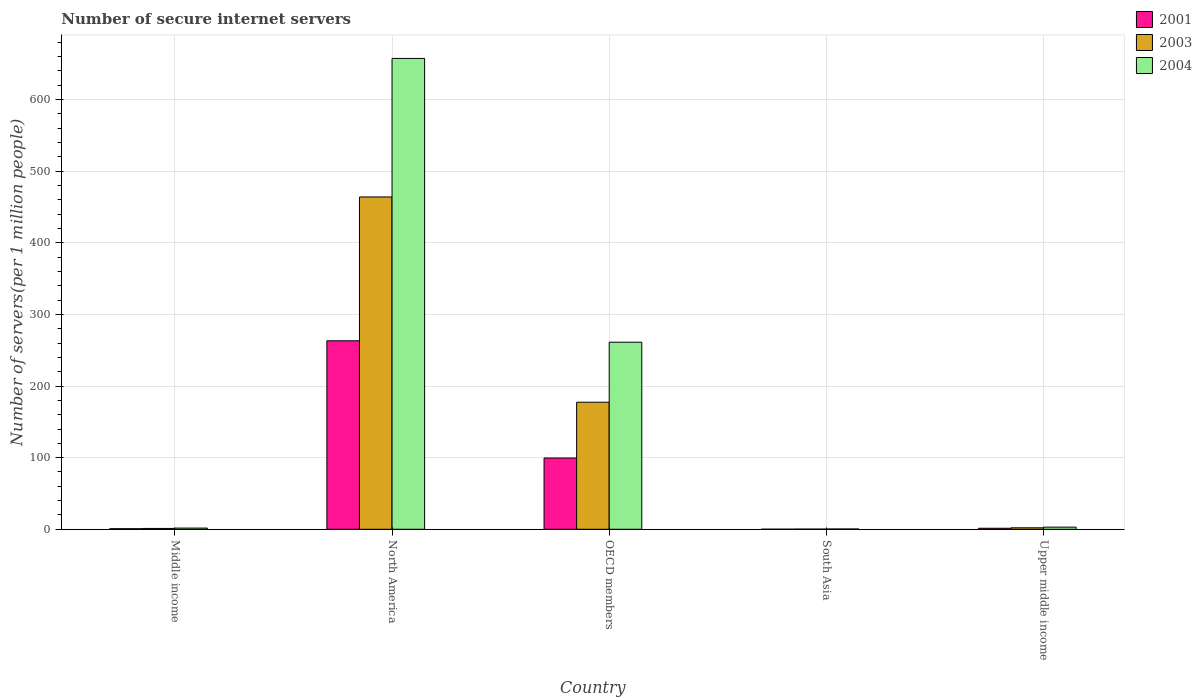How many different coloured bars are there?
Keep it short and to the point. 3. Are the number of bars per tick equal to the number of legend labels?
Provide a short and direct response. Yes. How many bars are there on the 2nd tick from the right?
Ensure brevity in your answer.  3. In how many cases, is the number of bars for a given country not equal to the number of legend labels?
Give a very brief answer. 0. What is the number of secure internet servers in 2003 in North America?
Your answer should be very brief. 464.07. Across all countries, what is the maximum number of secure internet servers in 2003?
Provide a short and direct response. 464.07. Across all countries, what is the minimum number of secure internet servers in 2001?
Your answer should be very brief. 0.1. In which country was the number of secure internet servers in 2003 minimum?
Keep it short and to the point. South Asia. What is the total number of secure internet servers in 2003 in the graph?
Provide a succinct answer. 644.94. What is the difference between the number of secure internet servers in 2004 in Middle income and that in Upper middle income?
Your answer should be compact. -1.33. What is the difference between the number of secure internet servers in 2001 in South Asia and the number of secure internet servers in 2004 in Upper middle income?
Give a very brief answer. -2.9. What is the average number of secure internet servers in 2003 per country?
Make the answer very short. 128.99. What is the difference between the number of secure internet servers of/in 2004 and number of secure internet servers of/in 2001 in North America?
Give a very brief answer. 394.33. What is the ratio of the number of secure internet servers in 2003 in North America to that in OECD members?
Offer a very short reply. 2.62. Is the number of secure internet servers in 2003 in North America less than that in Upper middle income?
Provide a succinct answer. No. Is the difference between the number of secure internet servers in 2004 in North America and South Asia greater than the difference between the number of secure internet servers in 2001 in North America and South Asia?
Provide a short and direct response. Yes. What is the difference between the highest and the second highest number of secure internet servers in 2001?
Give a very brief answer. -98.11. What is the difference between the highest and the lowest number of secure internet servers in 2001?
Provide a short and direct response. 263.14. In how many countries, is the number of secure internet servers in 2001 greater than the average number of secure internet servers in 2001 taken over all countries?
Make the answer very short. 2. Is the sum of the number of secure internet servers in 2003 in OECD members and South Asia greater than the maximum number of secure internet servers in 2001 across all countries?
Offer a very short reply. No. What does the 1st bar from the right in Middle income represents?
Offer a terse response. 2004. How many bars are there?
Ensure brevity in your answer.  15. Are all the bars in the graph horizontal?
Offer a very short reply. No. How many countries are there in the graph?
Ensure brevity in your answer.  5. What is the difference between two consecutive major ticks on the Y-axis?
Keep it short and to the point. 100. Does the graph contain any zero values?
Your response must be concise. No. Does the graph contain grids?
Your answer should be very brief. Yes. Where does the legend appear in the graph?
Your answer should be very brief. Top right. How many legend labels are there?
Offer a very short reply. 3. What is the title of the graph?
Ensure brevity in your answer.  Number of secure internet servers. What is the label or title of the X-axis?
Provide a short and direct response. Country. What is the label or title of the Y-axis?
Offer a terse response. Number of servers(per 1 million people). What is the Number of servers(per 1 million people) in 2001 in Middle income?
Your response must be concise. 0.78. What is the Number of servers(per 1 million people) in 2003 in Middle income?
Ensure brevity in your answer.  1.15. What is the Number of servers(per 1 million people) of 2004 in Middle income?
Your answer should be very brief. 1.67. What is the Number of servers(per 1 million people) of 2001 in North America?
Make the answer very short. 263.23. What is the Number of servers(per 1 million people) in 2003 in North America?
Keep it short and to the point. 464.07. What is the Number of servers(per 1 million people) in 2004 in North America?
Your answer should be compact. 657.56. What is the Number of servers(per 1 million people) of 2001 in OECD members?
Offer a terse response. 99.52. What is the Number of servers(per 1 million people) in 2003 in OECD members?
Your response must be concise. 177.43. What is the Number of servers(per 1 million people) in 2004 in OECD members?
Offer a very short reply. 261.25. What is the Number of servers(per 1 million people) of 2001 in South Asia?
Keep it short and to the point. 0.1. What is the Number of servers(per 1 million people) in 2003 in South Asia?
Provide a succinct answer. 0.23. What is the Number of servers(per 1 million people) of 2004 in South Asia?
Give a very brief answer. 0.36. What is the Number of servers(per 1 million people) in 2001 in Upper middle income?
Your response must be concise. 1.41. What is the Number of servers(per 1 million people) of 2003 in Upper middle income?
Give a very brief answer. 2.06. What is the Number of servers(per 1 million people) in 2004 in Upper middle income?
Offer a very short reply. 3. Across all countries, what is the maximum Number of servers(per 1 million people) of 2001?
Your answer should be compact. 263.23. Across all countries, what is the maximum Number of servers(per 1 million people) in 2003?
Your answer should be compact. 464.07. Across all countries, what is the maximum Number of servers(per 1 million people) in 2004?
Offer a terse response. 657.56. Across all countries, what is the minimum Number of servers(per 1 million people) in 2001?
Your answer should be very brief. 0.1. Across all countries, what is the minimum Number of servers(per 1 million people) of 2003?
Ensure brevity in your answer.  0.23. Across all countries, what is the minimum Number of servers(per 1 million people) in 2004?
Offer a terse response. 0.36. What is the total Number of servers(per 1 million people) in 2001 in the graph?
Offer a terse response. 365.04. What is the total Number of servers(per 1 million people) of 2003 in the graph?
Make the answer very short. 644.94. What is the total Number of servers(per 1 million people) of 2004 in the graph?
Offer a terse response. 923.84. What is the difference between the Number of servers(per 1 million people) of 2001 in Middle income and that in North America?
Offer a very short reply. -262.46. What is the difference between the Number of servers(per 1 million people) in 2003 in Middle income and that in North America?
Your answer should be very brief. -462.93. What is the difference between the Number of servers(per 1 million people) in 2004 in Middle income and that in North America?
Keep it short and to the point. -655.89. What is the difference between the Number of servers(per 1 million people) of 2001 in Middle income and that in OECD members?
Offer a terse response. -98.74. What is the difference between the Number of servers(per 1 million people) in 2003 in Middle income and that in OECD members?
Give a very brief answer. -176.28. What is the difference between the Number of servers(per 1 million people) of 2004 in Middle income and that in OECD members?
Make the answer very short. -259.58. What is the difference between the Number of servers(per 1 million people) of 2001 in Middle income and that in South Asia?
Provide a succinct answer. 0.68. What is the difference between the Number of servers(per 1 million people) in 2003 in Middle income and that in South Asia?
Keep it short and to the point. 0.92. What is the difference between the Number of servers(per 1 million people) of 2004 in Middle income and that in South Asia?
Ensure brevity in your answer.  1.31. What is the difference between the Number of servers(per 1 million people) of 2001 in Middle income and that in Upper middle income?
Make the answer very short. -0.63. What is the difference between the Number of servers(per 1 million people) of 2003 in Middle income and that in Upper middle income?
Offer a very short reply. -0.91. What is the difference between the Number of servers(per 1 million people) in 2004 in Middle income and that in Upper middle income?
Give a very brief answer. -1.33. What is the difference between the Number of servers(per 1 million people) of 2001 in North America and that in OECD members?
Ensure brevity in your answer.  163.72. What is the difference between the Number of servers(per 1 million people) of 2003 in North America and that in OECD members?
Offer a terse response. 286.65. What is the difference between the Number of servers(per 1 million people) in 2004 in North America and that in OECD members?
Provide a succinct answer. 396.32. What is the difference between the Number of servers(per 1 million people) in 2001 in North America and that in South Asia?
Give a very brief answer. 263.14. What is the difference between the Number of servers(per 1 million people) in 2003 in North America and that in South Asia?
Your response must be concise. 463.85. What is the difference between the Number of servers(per 1 million people) of 2004 in North America and that in South Asia?
Keep it short and to the point. 657.2. What is the difference between the Number of servers(per 1 million people) of 2001 in North America and that in Upper middle income?
Give a very brief answer. 261.83. What is the difference between the Number of servers(per 1 million people) of 2003 in North America and that in Upper middle income?
Make the answer very short. 462.01. What is the difference between the Number of servers(per 1 million people) of 2004 in North America and that in Upper middle income?
Ensure brevity in your answer.  654.57. What is the difference between the Number of servers(per 1 million people) of 2001 in OECD members and that in South Asia?
Offer a very short reply. 99.42. What is the difference between the Number of servers(per 1 million people) in 2003 in OECD members and that in South Asia?
Provide a short and direct response. 177.2. What is the difference between the Number of servers(per 1 million people) of 2004 in OECD members and that in South Asia?
Keep it short and to the point. 260.88. What is the difference between the Number of servers(per 1 million people) of 2001 in OECD members and that in Upper middle income?
Your response must be concise. 98.11. What is the difference between the Number of servers(per 1 million people) in 2003 in OECD members and that in Upper middle income?
Keep it short and to the point. 175.36. What is the difference between the Number of servers(per 1 million people) of 2004 in OECD members and that in Upper middle income?
Give a very brief answer. 258.25. What is the difference between the Number of servers(per 1 million people) of 2001 in South Asia and that in Upper middle income?
Ensure brevity in your answer.  -1.31. What is the difference between the Number of servers(per 1 million people) of 2003 in South Asia and that in Upper middle income?
Give a very brief answer. -1.83. What is the difference between the Number of servers(per 1 million people) of 2004 in South Asia and that in Upper middle income?
Your answer should be very brief. -2.63. What is the difference between the Number of servers(per 1 million people) of 2001 in Middle income and the Number of servers(per 1 million people) of 2003 in North America?
Offer a very short reply. -463.3. What is the difference between the Number of servers(per 1 million people) in 2001 in Middle income and the Number of servers(per 1 million people) in 2004 in North America?
Provide a succinct answer. -656.79. What is the difference between the Number of servers(per 1 million people) of 2003 in Middle income and the Number of servers(per 1 million people) of 2004 in North America?
Your response must be concise. -656.42. What is the difference between the Number of servers(per 1 million people) in 2001 in Middle income and the Number of servers(per 1 million people) in 2003 in OECD members?
Your answer should be very brief. -176.65. What is the difference between the Number of servers(per 1 million people) of 2001 in Middle income and the Number of servers(per 1 million people) of 2004 in OECD members?
Provide a short and direct response. -260.47. What is the difference between the Number of servers(per 1 million people) of 2003 in Middle income and the Number of servers(per 1 million people) of 2004 in OECD members?
Provide a succinct answer. -260.1. What is the difference between the Number of servers(per 1 million people) in 2001 in Middle income and the Number of servers(per 1 million people) in 2003 in South Asia?
Give a very brief answer. 0.55. What is the difference between the Number of servers(per 1 million people) in 2001 in Middle income and the Number of servers(per 1 million people) in 2004 in South Asia?
Ensure brevity in your answer.  0.41. What is the difference between the Number of servers(per 1 million people) of 2003 in Middle income and the Number of servers(per 1 million people) of 2004 in South Asia?
Your answer should be very brief. 0.78. What is the difference between the Number of servers(per 1 million people) of 2001 in Middle income and the Number of servers(per 1 million people) of 2003 in Upper middle income?
Provide a succinct answer. -1.28. What is the difference between the Number of servers(per 1 million people) of 2001 in Middle income and the Number of servers(per 1 million people) of 2004 in Upper middle income?
Give a very brief answer. -2.22. What is the difference between the Number of servers(per 1 million people) in 2003 in Middle income and the Number of servers(per 1 million people) in 2004 in Upper middle income?
Give a very brief answer. -1.85. What is the difference between the Number of servers(per 1 million people) in 2001 in North America and the Number of servers(per 1 million people) in 2003 in OECD members?
Your response must be concise. 85.81. What is the difference between the Number of servers(per 1 million people) in 2001 in North America and the Number of servers(per 1 million people) in 2004 in OECD members?
Ensure brevity in your answer.  1.99. What is the difference between the Number of servers(per 1 million people) of 2003 in North America and the Number of servers(per 1 million people) of 2004 in OECD members?
Offer a terse response. 202.83. What is the difference between the Number of servers(per 1 million people) in 2001 in North America and the Number of servers(per 1 million people) in 2003 in South Asia?
Offer a very short reply. 263.01. What is the difference between the Number of servers(per 1 million people) in 2001 in North America and the Number of servers(per 1 million people) in 2004 in South Asia?
Your answer should be very brief. 262.87. What is the difference between the Number of servers(per 1 million people) in 2003 in North America and the Number of servers(per 1 million people) in 2004 in South Asia?
Provide a short and direct response. 463.71. What is the difference between the Number of servers(per 1 million people) in 2001 in North America and the Number of servers(per 1 million people) in 2003 in Upper middle income?
Offer a very short reply. 261.17. What is the difference between the Number of servers(per 1 million people) of 2001 in North America and the Number of servers(per 1 million people) of 2004 in Upper middle income?
Offer a terse response. 260.24. What is the difference between the Number of servers(per 1 million people) in 2003 in North America and the Number of servers(per 1 million people) in 2004 in Upper middle income?
Provide a succinct answer. 461.08. What is the difference between the Number of servers(per 1 million people) of 2001 in OECD members and the Number of servers(per 1 million people) of 2003 in South Asia?
Your response must be concise. 99.29. What is the difference between the Number of servers(per 1 million people) in 2001 in OECD members and the Number of servers(per 1 million people) in 2004 in South Asia?
Ensure brevity in your answer.  99.15. What is the difference between the Number of servers(per 1 million people) of 2003 in OECD members and the Number of servers(per 1 million people) of 2004 in South Asia?
Offer a very short reply. 177.06. What is the difference between the Number of servers(per 1 million people) in 2001 in OECD members and the Number of servers(per 1 million people) in 2003 in Upper middle income?
Offer a very short reply. 97.45. What is the difference between the Number of servers(per 1 million people) in 2001 in OECD members and the Number of servers(per 1 million people) in 2004 in Upper middle income?
Your response must be concise. 96.52. What is the difference between the Number of servers(per 1 million people) in 2003 in OECD members and the Number of servers(per 1 million people) in 2004 in Upper middle income?
Offer a very short reply. 174.43. What is the difference between the Number of servers(per 1 million people) of 2001 in South Asia and the Number of servers(per 1 million people) of 2003 in Upper middle income?
Give a very brief answer. -1.96. What is the difference between the Number of servers(per 1 million people) of 2001 in South Asia and the Number of servers(per 1 million people) of 2004 in Upper middle income?
Your response must be concise. -2.9. What is the difference between the Number of servers(per 1 million people) of 2003 in South Asia and the Number of servers(per 1 million people) of 2004 in Upper middle income?
Your answer should be compact. -2.77. What is the average Number of servers(per 1 million people) of 2001 per country?
Provide a short and direct response. 73.01. What is the average Number of servers(per 1 million people) in 2003 per country?
Ensure brevity in your answer.  128.99. What is the average Number of servers(per 1 million people) of 2004 per country?
Ensure brevity in your answer.  184.77. What is the difference between the Number of servers(per 1 million people) in 2001 and Number of servers(per 1 million people) in 2003 in Middle income?
Provide a succinct answer. -0.37. What is the difference between the Number of servers(per 1 million people) of 2001 and Number of servers(per 1 million people) of 2004 in Middle income?
Give a very brief answer. -0.89. What is the difference between the Number of servers(per 1 million people) in 2003 and Number of servers(per 1 million people) in 2004 in Middle income?
Provide a short and direct response. -0.52. What is the difference between the Number of servers(per 1 million people) of 2001 and Number of servers(per 1 million people) of 2003 in North America?
Give a very brief answer. -200.84. What is the difference between the Number of servers(per 1 million people) of 2001 and Number of servers(per 1 million people) of 2004 in North America?
Keep it short and to the point. -394.33. What is the difference between the Number of servers(per 1 million people) of 2003 and Number of servers(per 1 million people) of 2004 in North America?
Offer a very short reply. -193.49. What is the difference between the Number of servers(per 1 million people) in 2001 and Number of servers(per 1 million people) in 2003 in OECD members?
Your answer should be very brief. -77.91. What is the difference between the Number of servers(per 1 million people) of 2001 and Number of servers(per 1 million people) of 2004 in OECD members?
Provide a short and direct response. -161.73. What is the difference between the Number of servers(per 1 million people) in 2003 and Number of servers(per 1 million people) in 2004 in OECD members?
Ensure brevity in your answer.  -83.82. What is the difference between the Number of servers(per 1 million people) in 2001 and Number of servers(per 1 million people) in 2003 in South Asia?
Your answer should be very brief. -0.13. What is the difference between the Number of servers(per 1 million people) of 2001 and Number of servers(per 1 million people) of 2004 in South Asia?
Keep it short and to the point. -0.27. What is the difference between the Number of servers(per 1 million people) of 2003 and Number of servers(per 1 million people) of 2004 in South Asia?
Offer a terse response. -0.14. What is the difference between the Number of servers(per 1 million people) in 2001 and Number of servers(per 1 million people) in 2003 in Upper middle income?
Offer a terse response. -0.65. What is the difference between the Number of servers(per 1 million people) of 2001 and Number of servers(per 1 million people) of 2004 in Upper middle income?
Keep it short and to the point. -1.59. What is the difference between the Number of servers(per 1 million people) of 2003 and Number of servers(per 1 million people) of 2004 in Upper middle income?
Keep it short and to the point. -0.94. What is the ratio of the Number of servers(per 1 million people) in 2001 in Middle income to that in North America?
Your answer should be very brief. 0. What is the ratio of the Number of servers(per 1 million people) in 2003 in Middle income to that in North America?
Ensure brevity in your answer.  0. What is the ratio of the Number of servers(per 1 million people) of 2004 in Middle income to that in North America?
Your answer should be very brief. 0. What is the ratio of the Number of servers(per 1 million people) in 2001 in Middle income to that in OECD members?
Offer a very short reply. 0.01. What is the ratio of the Number of servers(per 1 million people) of 2003 in Middle income to that in OECD members?
Your answer should be compact. 0.01. What is the ratio of the Number of servers(per 1 million people) of 2004 in Middle income to that in OECD members?
Your answer should be very brief. 0.01. What is the ratio of the Number of servers(per 1 million people) of 2001 in Middle income to that in South Asia?
Your answer should be compact. 7.86. What is the ratio of the Number of servers(per 1 million people) in 2003 in Middle income to that in South Asia?
Give a very brief answer. 5.04. What is the ratio of the Number of servers(per 1 million people) of 2004 in Middle income to that in South Asia?
Your answer should be compact. 4.59. What is the ratio of the Number of servers(per 1 million people) in 2001 in Middle income to that in Upper middle income?
Offer a very short reply. 0.55. What is the ratio of the Number of servers(per 1 million people) of 2003 in Middle income to that in Upper middle income?
Provide a short and direct response. 0.56. What is the ratio of the Number of servers(per 1 million people) of 2004 in Middle income to that in Upper middle income?
Your response must be concise. 0.56. What is the ratio of the Number of servers(per 1 million people) of 2001 in North America to that in OECD members?
Give a very brief answer. 2.65. What is the ratio of the Number of servers(per 1 million people) of 2003 in North America to that in OECD members?
Give a very brief answer. 2.62. What is the ratio of the Number of servers(per 1 million people) of 2004 in North America to that in OECD members?
Your answer should be very brief. 2.52. What is the ratio of the Number of servers(per 1 million people) of 2001 in North America to that in South Asia?
Provide a short and direct response. 2663.04. What is the ratio of the Number of servers(per 1 million people) in 2003 in North America to that in South Asia?
Provide a short and direct response. 2035.75. What is the ratio of the Number of servers(per 1 million people) of 2004 in North America to that in South Asia?
Your response must be concise. 1805.77. What is the ratio of the Number of servers(per 1 million people) in 2001 in North America to that in Upper middle income?
Your response must be concise. 186.8. What is the ratio of the Number of servers(per 1 million people) of 2003 in North America to that in Upper middle income?
Provide a succinct answer. 225.17. What is the ratio of the Number of servers(per 1 million people) of 2004 in North America to that in Upper middle income?
Keep it short and to the point. 219.48. What is the ratio of the Number of servers(per 1 million people) in 2001 in OECD members to that in South Asia?
Your response must be concise. 1006.76. What is the ratio of the Number of servers(per 1 million people) of 2003 in OECD members to that in South Asia?
Offer a very short reply. 778.31. What is the ratio of the Number of servers(per 1 million people) of 2004 in OECD members to that in South Asia?
Offer a terse response. 717.42. What is the ratio of the Number of servers(per 1 million people) in 2001 in OECD members to that in Upper middle income?
Give a very brief answer. 70.62. What is the ratio of the Number of servers(per 1 million people) in 2003 in OECD members to that in Upper middle income?
Give a very brief answer. 86.09. What is the ratio of the Number of servers(per 1 million people) in 2004 in OECD members to that in Upper middle income?
Keep it short and to the point. 87.2. What is the ratio of the Number of servers(per 1 million people) of 2001 in South Asia to that in Upper middle income?
Provide a succinct answer. 0.07. What is the ratio of the Number of servers(per 1 million people) of 2003 in South Asia to that in Upper middle income?
Offer a very short reply. 0.11. What is the ratio of the Number of servers(per 1 million people) of 2004 in South Asia to that in Upper middle income?
Provide a short and direct response. 0.12. What is the difference between the highest and the second highest Number of servers(per 1 million people) in 2001?
Offer a terse response. 163.72. What is the difference between the highest and the second highest Number of servers(per 1 million people) in 2003?
Give a very brief answer. 286.65. What is the difference between the highest and the second highest Number of servers(per 1 million people) of 2004?
Your answer should be compact. 396.32. What is the difference between the highest and the lowest Number of servers(per 1 million people) of 2001?
Your answer should be compact. 263.14. What is the difference between the highest and the lowest Number of servers(per 1 million people) in 2003?
Your answer should be very brief. 463.85. What is the difference between the highest and the lowest Number of servers(per 1 million people) in 2004?
Provide a short and direct response. 657.2. 